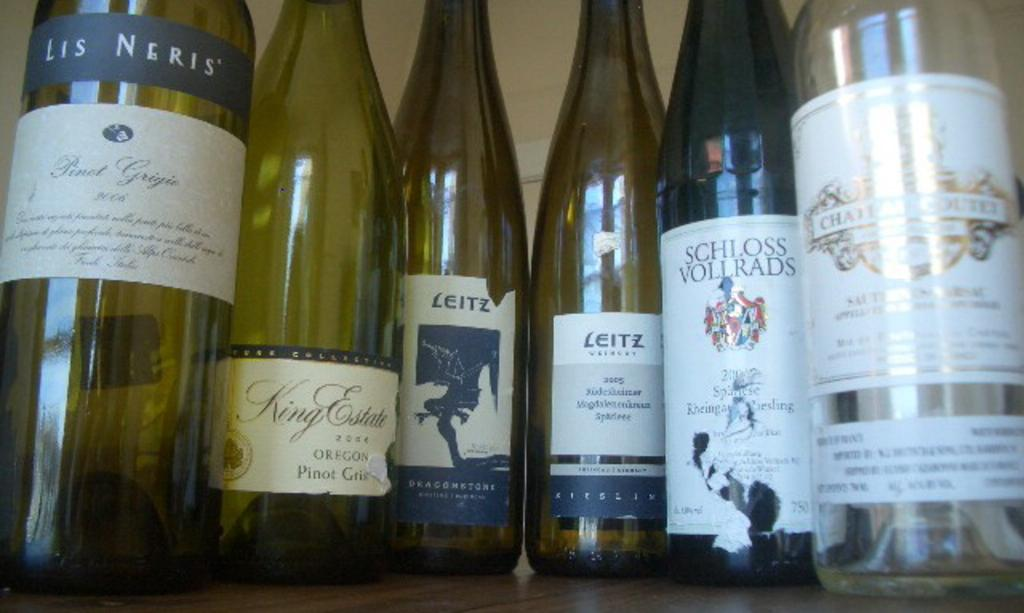Provide a one-sentence caption for the provided image. One bottle of Les Neris wine, one bottle of King Estates, two bottles of Leitz, one bottle of Schloss Vollrads and one additional bottle of wine are pictured. 